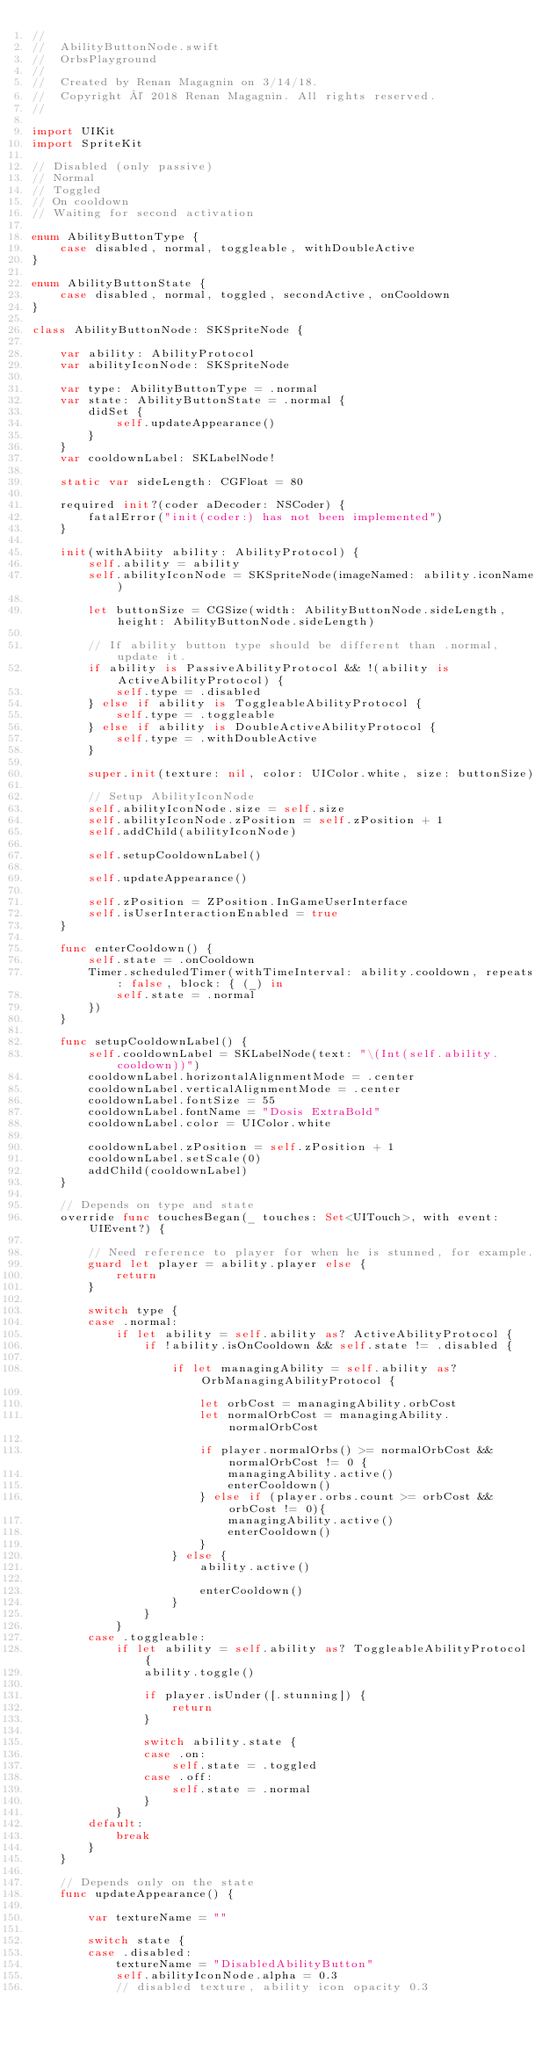Convert code to text. <code><loc_0><loc_0><loc_500><loc_500><_Swift_>//
//  AbilityButtonNode.swift
//  OrbsPlayground
//
//  Created by Renan Magagnin on 3/14/18.
//  Copyright © 2018 Renan Magagnin. All rights reserved.
//

import UIKit
import SpriteKit

// Disabled (only passive)
// Normal
// Toggled
// On cooldown
// Waiting for second activation

enum AbilityButtonType {
    case disabled, normal, toggleable, withDoubleActive
}

enum AbilityButtonState {
    case disabled, normal, toggled, secondActive, onCooldown
}

class AbilityButtonNode: SKSpriteNode {
    
    var ability: AbilityProtocol
    var abilityIconNode: SKSpriteNode
    
    var type: AbilityButtonType = .normal
    var state: AbilityButtonState = .normal {
        didSet {
            self.updateAppearance()
        }
    }
    var cooldownLabel: SKLabelNode!
    
    static var sideLength: CGFloat = 80
    
    required init?(coder aDecoder: NSCoder) {
        fatalError("init(coder:) has not been implemented")
    }
    
    init(withAbiity ability: AbilityProtocol) {
        self.ability = ability
        self.abilityIconNode = SKSpriteNode(imageNamed: ability.iconName)
        
        let buttonSize = CGSize(width: AbilityButtonNode.sideLength, height: AbilityButtonNode.sideLength)
        
        // If ability button type should be different than .normal, update it.
        if ability is PassiveAbilityProtocol && !(ability is ActiveAbilityProtocol) {
            self.type = .disabled
        } else if ability is ToggleableAbilityProtocol {
            self.type = .toggleable
        } else if ability is DoubleActiveAbilityProtocol {
            self.type = .withDoubleActive
        }
        
        super.init(texture: nil, color: UIColor.white, size: buttonSize)
        
        // Setup AbilityIconNode
        self.abilityIconNode.size = self.size
        self.abilityIconNode.zPosition = self.zPosition + 1
        self.addChild(abilityIconNode)
        
        self.setupCooldownLabel()
        
        self.updateAppearance()
        
        self.zPosition = ZPosition.InGameUserInterface
        self.isUserInteractionEnabled = true
    }
    
    func enterCooldown() {
        self.state = .onCooldown
        Timer.scheduledTimer(withTimeInterval: ability.cooldown, repeats: false, block: { (_) in
            self.state = .normal
        })
    }
    
    func setupCooldownLabel() {
        self.cooldownLabel = SKLabelNode(text: "\(Int(self.ability.cooldown))")
        cooldownLabel.horizontalAlignmentMode = .center
        cooldownLabel.verticalAlignmentMode = .center
        cooldownLabel.fontSize = 55
        cooldownLabel.fontName = "Dosis ExtraBold"
        cooldownLabel.color = UIColor.white
        
        cooldownLabel.zPosition = self.zPosition + 1
        cooldownLabel.setScale(0)
        addChild(cooldownLabel)
    }
    
    // Depends on type and state
    override func touchesBegan(_ touches: Set<UITouch>, with event: UIEvent?) {
        
        // Need reference to player for when he is stunned, for example.
        guard let player = ability.player else {
            return
        }
        
        switch type {
        case .normal:
            if let ability = self.ability as? ActiveAbilityProtocol {
                if !ability.isOnCooldown && self.state != .disabled {
                    
                    if let managingAbility = self.ability as? OrbManagingAbilityProtocol {
                        
                        let orbCost = managingAbility.orbCost
                        let normalOrbCost = managingAbility.normalOrbCost
                        
                        if player.normalOrbs() >= normalOrbCost && normalOrbCost != 0 {
                            managingAbility.active()
                            enterCooldown()
                        } else if (player.orbs.count >= orbCost && orbCost != 0){
                            managingAbility.active()
                            enterCooldown()
                        }
                    } else {
                        ability.active()
                        
                        enterCooldown()
                    }
                }
            }
        case .toggleable:
            if let ability = self.ability as? ToggleableAbilityProtocol {
                ability.toggle()
                
                if player.isUnder([.stunning]) {
                    return
                }
                
                switch ability.state {
                case .on:
                    self.state = .toggled
                case .off:
                    self.state = .normal
                }
            }
        default:
            break
        }
    }
    
    // Depends only on the state
    func updateAppearance() {
        
        var textureName = ""
        
        switch state {
        case .disabled:
            textureName = "DisabledAbilityButton"
            self.abilityIconNode.alpha = 0.3
            // disabled texture, ability icon opacity 0.3</code> 